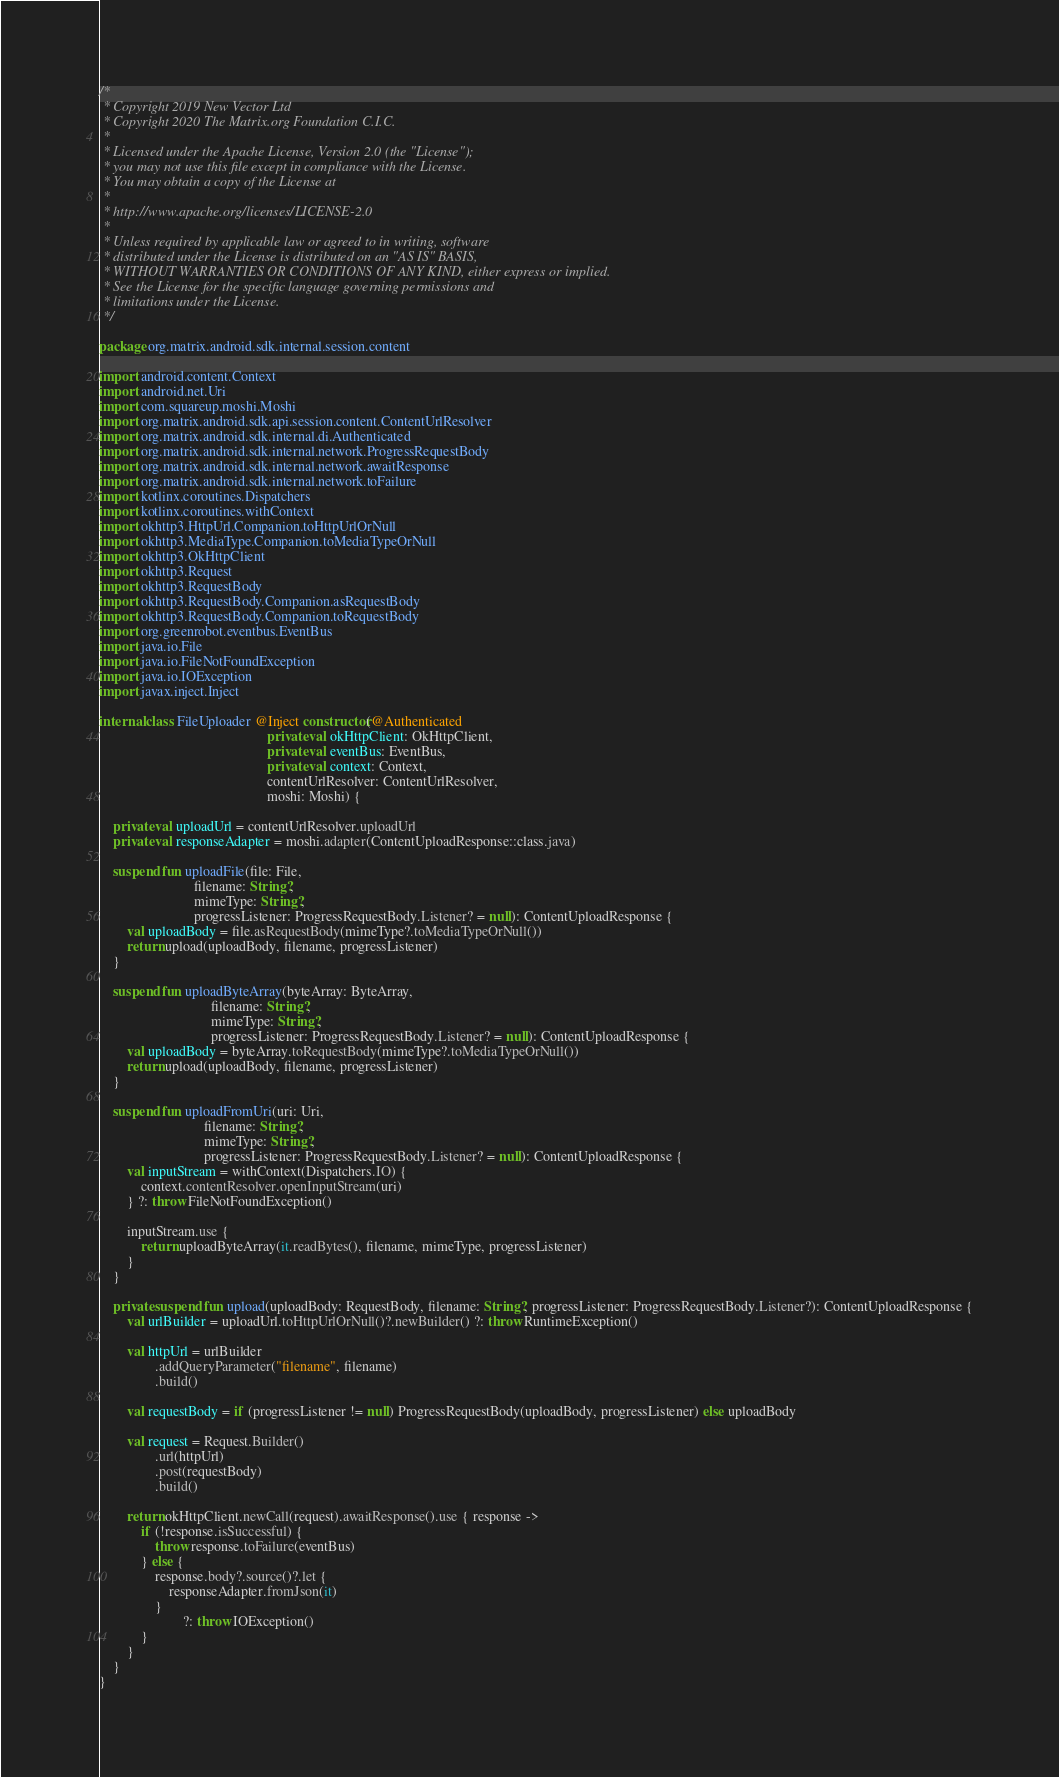Convert code to text. <code><loc_0><loc_0><loc_500><loc_500><_Kotlin_>/*
 * Copyright 2019 New Vector Ltd
 * Copyright 2020 The Matrix.org Foundation C.I.C.
 *
 * Licensed under the Apache License, Version 2.0 (the "License");
 * you may not use this file except in compliance with the License.
 * You may obtain a copy of the License at
 *
 * http://www.apache.org/licenses/LICENSE-2.0
 *
 * Unless required by applicable law or agreed to in writing, software
 * distributed under the License is distributed on an "AS IS" BASIS,
 * WITHOUT WARRANTIES OR CONDITIONS OF ANY KIND, either express or implied.
 * See the License for the specific language governing permissions and
 * limitations under the License.
 */

package org.matrix.android.sdk.internal.session.content

import android.content.Context
import android.net.Uri
import com.squareup.moshi.Moshi
import org.matrix.android.sdk.api.session.content.ContentUrlResolver
import org.matrix.android.sdk.internal.di.Authenticated
import org.matrix.android.sdk.internal.network.ProgressRequestBody
import org.matrix.android.sdk.internal.network.awaitResponse
import org.matrix.android.sdk.internal.network.toFailure
import kotlinx.coroutines.Dispatchers
import kotlinx.coroutines.withContext
import okhttp3.HttpUrl.Companion.toHttpUrlOrNull
import okhttp3.MediaType.Companion.toMediaTypeOrNull
import okhttp3.OkHttpClient
import okhttp3.Request
import okhttp3.RequestBody
import okhttp3.RequestBody.Companion.asRequestBody
import okhttp3.RequestBody.Companion.toRequestBody
import org.greenrobot.eventbus.EventBus
import java.io.File
import java.io.FileNotFoundException
import java.io.IOException
import javax.inject.Inject

internal class FileUploader @Inject constructor(@Authenticated
                                                private val okHttpClient: OkHttpClient,
                                                private val eventBus: EventBus,
                                                private val context: Context,
                                                contentUrlResolver: ContentUrlResolver,
                                                moshi: Moshi) {

    private val uploadUrl = contentUrlResolver.uploadUrl
    private val responseAdapter = moshi.adapter(ContentUploadResponse::class.java)

    suspend fun uploadFile(file: File,
                           filename: String?,
                           mimeType: String?,
                           progressListener: ProgressRequestBody.Listener? = null): ContentUploadResponse {
        val uploadBody = file.asRequestBody(mimeType?.toMediaTypeOrNull())
        return upload(uploadBody, filename, progressListener)
    }

    suspend fun uploadByteArray(byteArray: ByteArray,
                                filename: String?,
                                mimeType: String?,
                                progressListener: ProgressRequestBody.Listener? = null): ContentUploadResponse {
        val uploadBody = byteArray.toRequestBody(mimeType?.toMediaTypeOrNull())
        return upload(uploadBody, filename, progressListener)
    }

    suspend fun uploadFromUri(uri: Uri,
                              filename: String?,
                              mimeType: String?,
                              progressListener: ProgressRequestBody.Listener? = null): ContentUploadResponse {
        val inputStream = withContext(Dispatchers.IO) {
            context.contentResolver.openInputStream(uri)
        } ?: throw FileNotFoundException()

        inputStream.use {
            return uploadByteArray(it.readBytes(), filename, mimeType, progressListener)
        }
    }

    private suspend fun upload(uploadBody: RequestBody, filename: String?, progressListener: ProgressRequestBody.Listener?): ContentUploadResponse {
        val urlBuilder = uploadUrl.toHttpUrlOrNull()?.newBuilder() ?: throw RuntimeException()

        val httpUrl = urlBuilder
                .addQueryParameter("filename", filename)
                .build()

        val requestBody = if (progressListener != null) ProgressRequestBody(uploadBody, progressListener) else uploadBody

        val request = Request.Builder()
                .url(httpUrl)
                .post(requestBody)
                .build()

        return okHttpClient.newCall(request).awaitResponse().use { response ->
            if (!response.isSuccessful) {
                throw response.toFailure(eventBus)
            } else {
                response.body?.source()?.let {
                    responseAdapter.fromJson(it)
                }
                        ?: throw IOException()
            }
        }
    }
}
</code> 